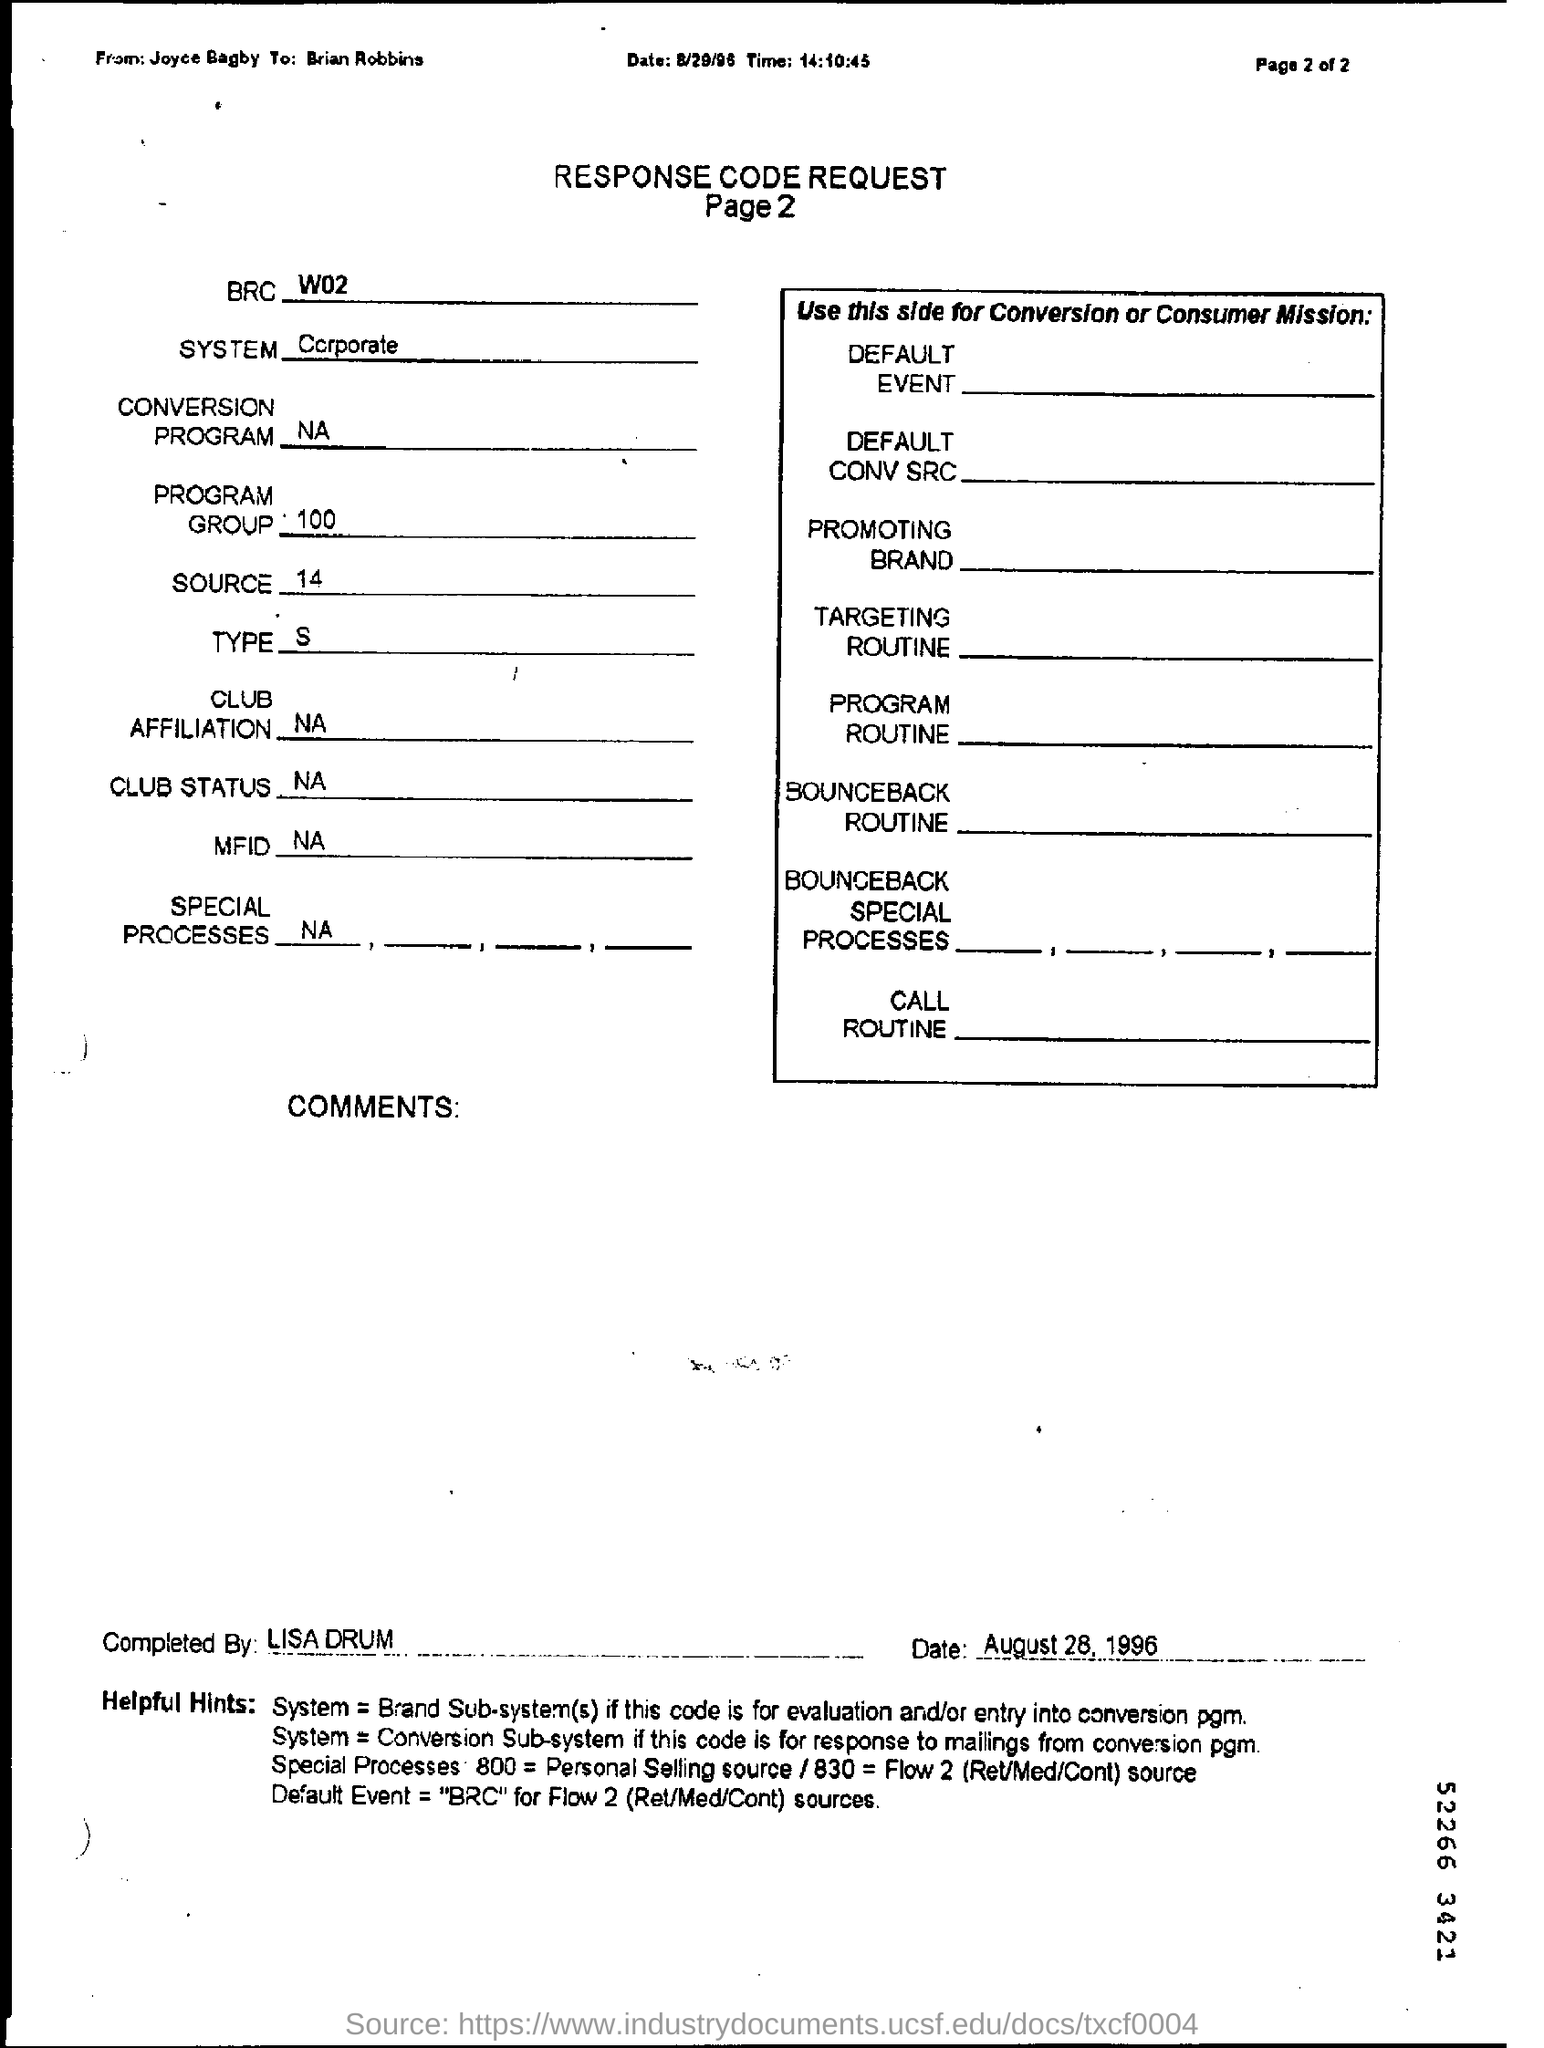Mention page number below response code request ?
Keep it short and to the point. Page 2. Whom is this response code request from ?
Give a very brief answer. Joyce bagby. To whom is response code request written ?
Your answer should be very brief. Brian Robbins. Who completed this response code request ?
Give a very brief answer. Lisa Drum. 